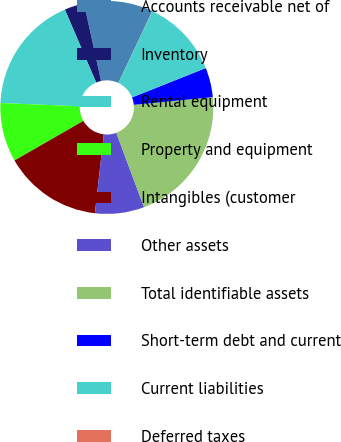Convert chart to OTSL. <chart><loc_0><loc_0><loc_500><loc_500><pie_chart><fcel>Accounts receivable net of<fcel>Inventory<fcel>Rental equipment<fcel>Property and equipment<fcel>Intangibles (customer<fcel>Other assets<fcel>Total identifiable assets<fcel>Short-term debt and current<fcel>Current liabilities<fcel>Deferred taxes<nl><fcel>10.45%<fcel>3.01%<fcel>17.89%<fcel>8.96%<fcel>14.91%<fcel>7.47%<fcel>20.86%<fcel>4.49%<fcel>11.93%<fcel>0.03%<nl></chart> 